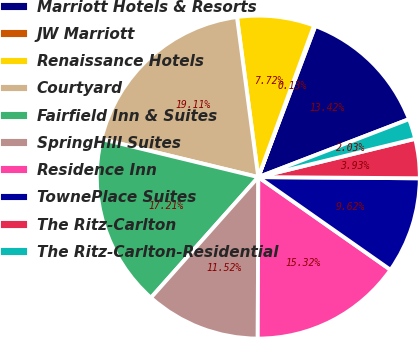Convert chart. <chart><loc_0><loc_0><loc_500><loc_500><pie_chart><fcel>Marriott Hotels & Resorts<fcel>JW Marriott<fcel>Renaissance Hotels<fcel>Courtyard<fcel>Fairfield Inn & Suites<fcel>SpringHill Suites<fcel>Residence Inn<fcel>TownePlace Suites<fcel>The Ritz-Carlton<fcel>The Ritz-Carlton-Residential<nl><fcel>13.42%<fcel>0.13%<fcel>7.72%<fcel>19.11%<fcel>17.21%<fcel>11.52%<fcel>15.32%<fcel>9.62%<fcel>3.93%<fcel>2.03%<nl></chart> 